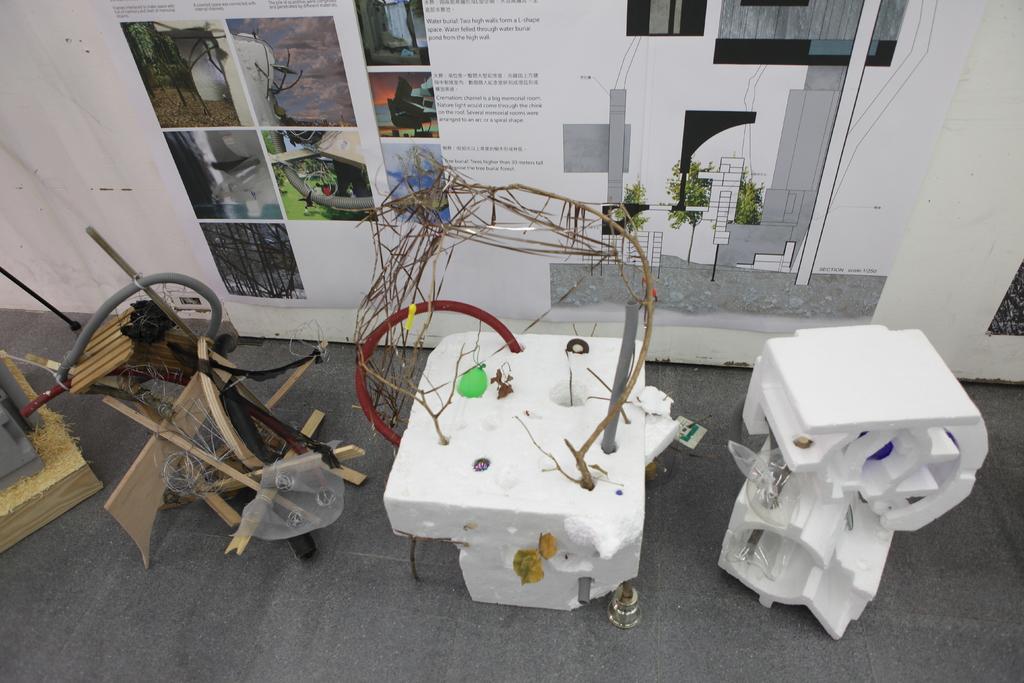How would you summarize this image in a sentence or two? In this picture there are wooden objects and there are thermocol objects. At the back there is a poster on the wall. On the poster there is text and there are pictures of trees. 